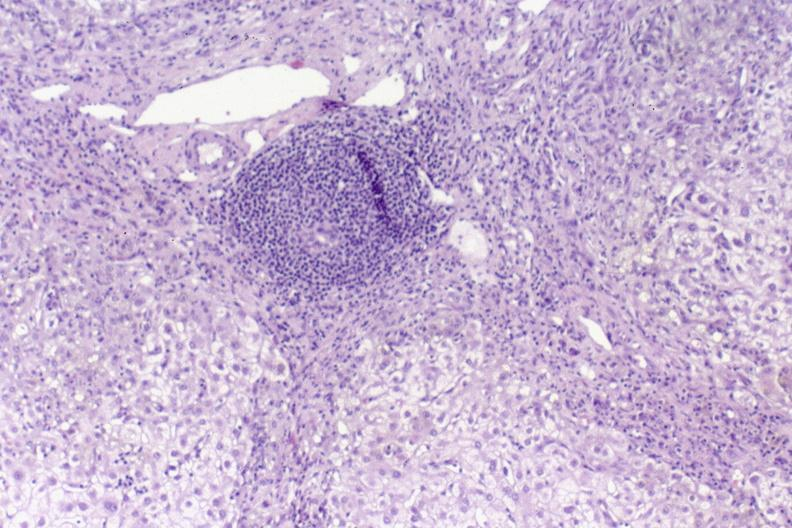does this image show primary biliary cirrhosis?
Answer the question using a single word or phrase. Yes 